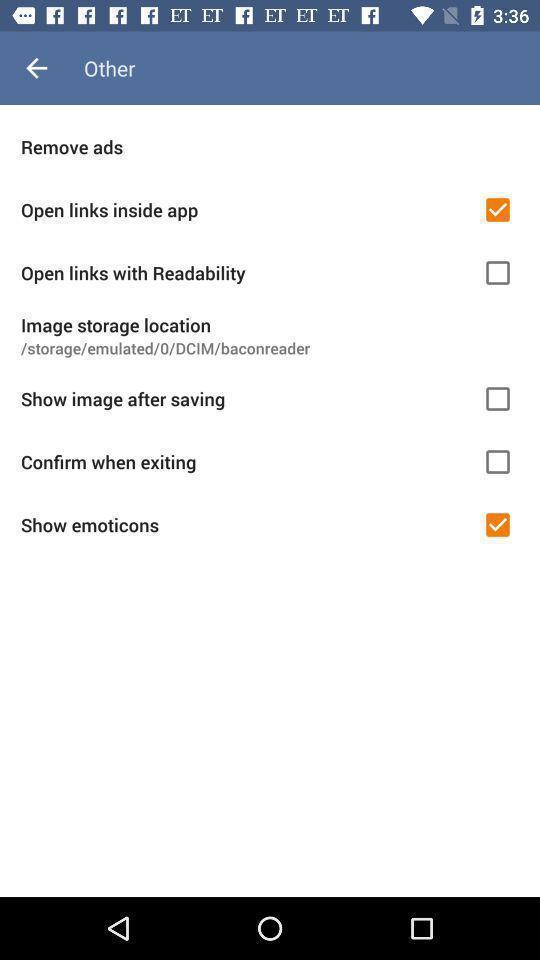What can you discern from this picture? Page showing different other options on an app. 